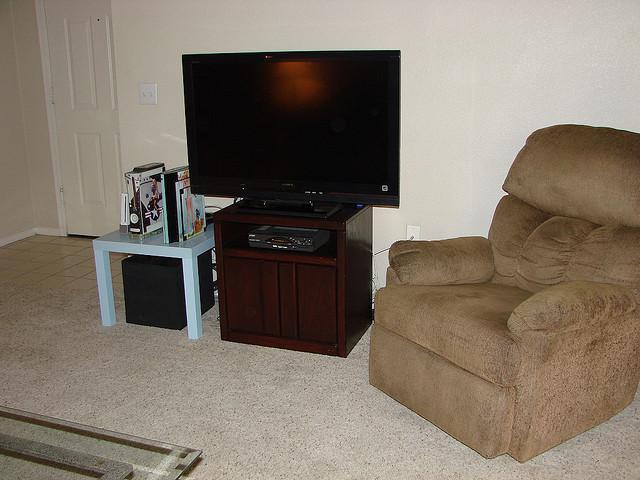How many books are visible?
Give a very brief answer. 1. How many elephants are facing the camera?
Give a very brief answer. 0. 